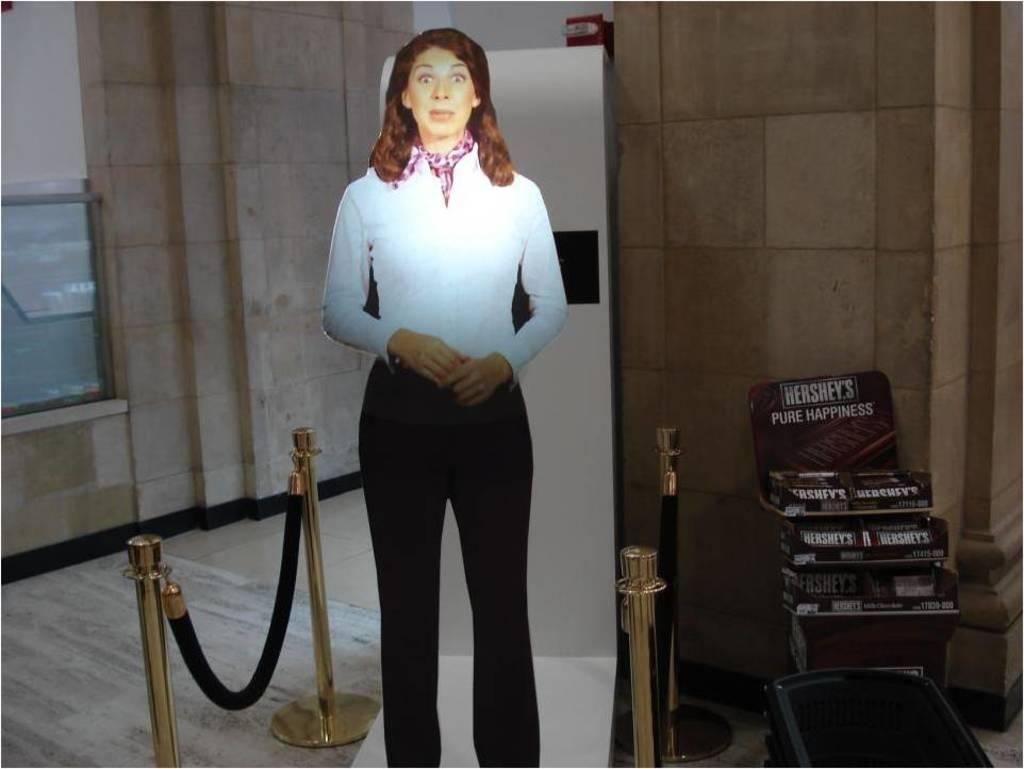<image>
Describe the image concisely. A cardboard cutout of a standing woman next to a Hershey's chocolate display. 